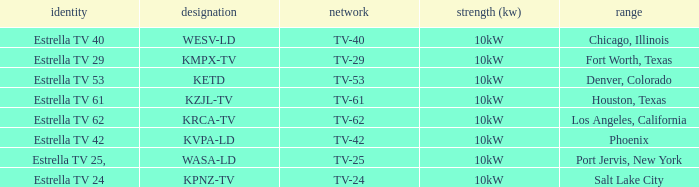Which area did estrella tv 62 provide coverage for? Los Angeles, California. Can you give me this table as a dict? {'header': ['identity', 'designation', 'network', 'strength (kw)', 'range'], 'rows': [['Estrella TV 40', 'WESV-LD', 'TV-40', '10kW', 'Chicago, Illinois'], ['Estrella TV 29', 'KMPX-TV', 'TV-29', '10kW', 'Fort Worth, Texas'], ['Estrella TV 53', 'KETD', 'TV-53', '10kW', 'Denver, Colorado'], ['Estrella TV 61', 'KZJL-TV', 'TV-61', '10kW', 'Houston, Texas'], ['Estrella TV 62', 'KRCA-TV', 'TV-62', '10kW', 'Los Angeles, California'], ['Estrella TV 42', 'KVPA-LD', 'TV-42', '10kW', 'Phoenix'], ['Estrella TV 25,', 'WASA-LD', 'TV-25', '10kW', 'Port Jervis, New York'], ['Estrella TV 24', 'KPNZ-TV', 'TV-24', '10kW', 'Salt Lake City']]} 